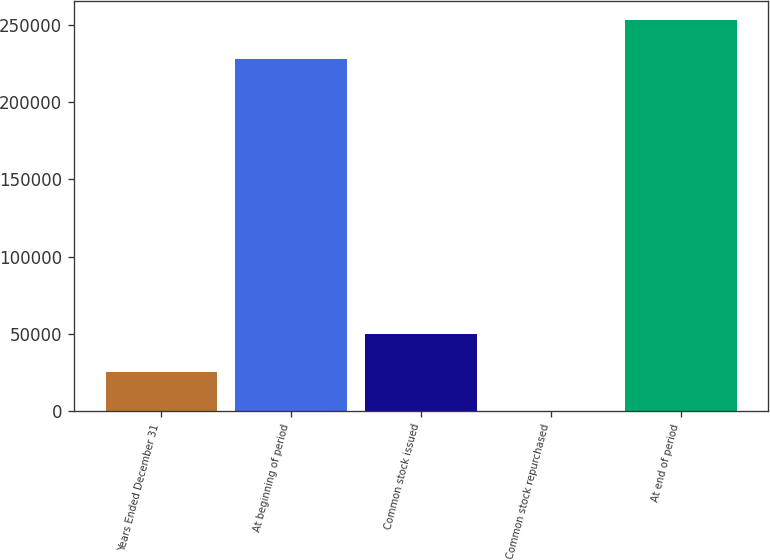Convert chart. <chart><loc_0><loc_0><loc_500><loc_500><bar_chart><fcel>Years Ended December 31<fcel>At beginning of period<fcel>Common stock issued<fcel>Common stock repurchased<fcel>At end of period<nl><fcel>25096<fcel>227891<fcel>50044<fcel>148<fcel>252839<nl></chart> 